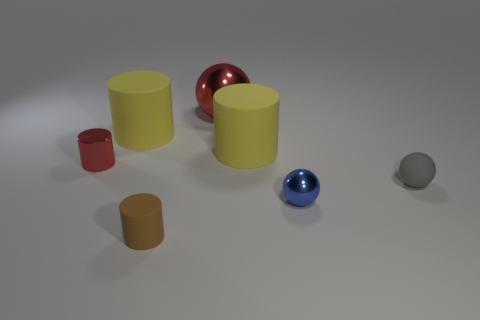Subtract all rubber cylinders. How many cylinders are left? 1 Add 2 small purple spheres. How many objects exist? 9 Subtract 2 cylinders. How many cylinders are left? 2 Subtract all red cylinders. How many cylinders are left? 3 Subtract all cylinders. How many objects are left? 3 Subtract all yellow balls. Subtract all purple cubes. How many balls are left? 3 Subtract all gray cylinders. How many brown balls are left? 0 Subtract all brown matte objects. Subtract all tiny gray objects. How many objects are left? 5 Add 1 large shiny spheres. How many large shiny spheres are left? 2 Add 7 large objects. How many large objects exist? 10 